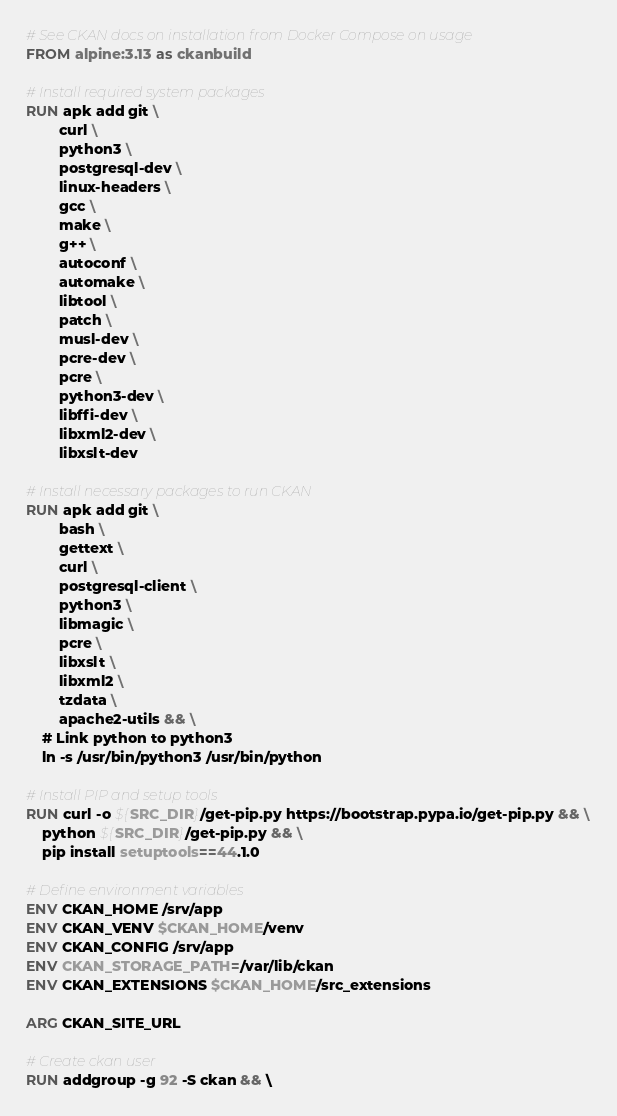<code> <loc_0><loc_0><loc_500><loc_500><_Dockerfile_># See CKAN docs on installation from Docker Compose on usage
FROM alpine:3.13 as ckanbuild

# Install required system packages
RUN apk add git \
        curl \
        python3 \
        postgresql-dev \
        linux-headers \
        gcc \
        make \
        g++ \
        autoconf \
        automake \
        libtool \
        patch \
        musl-dev \
        pcre-dev \
        pcre \
        python3-dev \
        libffi-dev \
        libxml2-dev \
        libxslt-dev

# Install necessary packages to run CKAN
RUN apk add git \
        bash \
        gettext \
        curl \
        postgresql-client \
        python3 \
        libmagic \
        pcre \
        libxslt \
        libxml2 \
        tzdata \
        apache2-utils && \
    # Link python to python3
    ln -s /usr/bin/python3 /usr/bin/python

# Install PIP and setup tools
RUN curl -o ${SRC_DIR}/get-pip.py https://bootstrap.pypa.io/get-pip.py && \
    python ${SRC_DIR}/get-pip.py && \
    pip install setuptools==44.1.0

# Define environment variables
ENV CKAN_HOME /srv/app
ENV CKAN_VENV $CKAN_HOME/venv
ENV CKAN_CONFIG /srv/app
ENV CKAN_STORAGE_PATH=/var/lib/ckan
ENV CKAN_EXTENSIONS $CKAN_HOME/src_extensions

ARG CKAN_SITE_URL

# Create ckan user
RUN addgroup -g 92 -S ckan && \</code> 